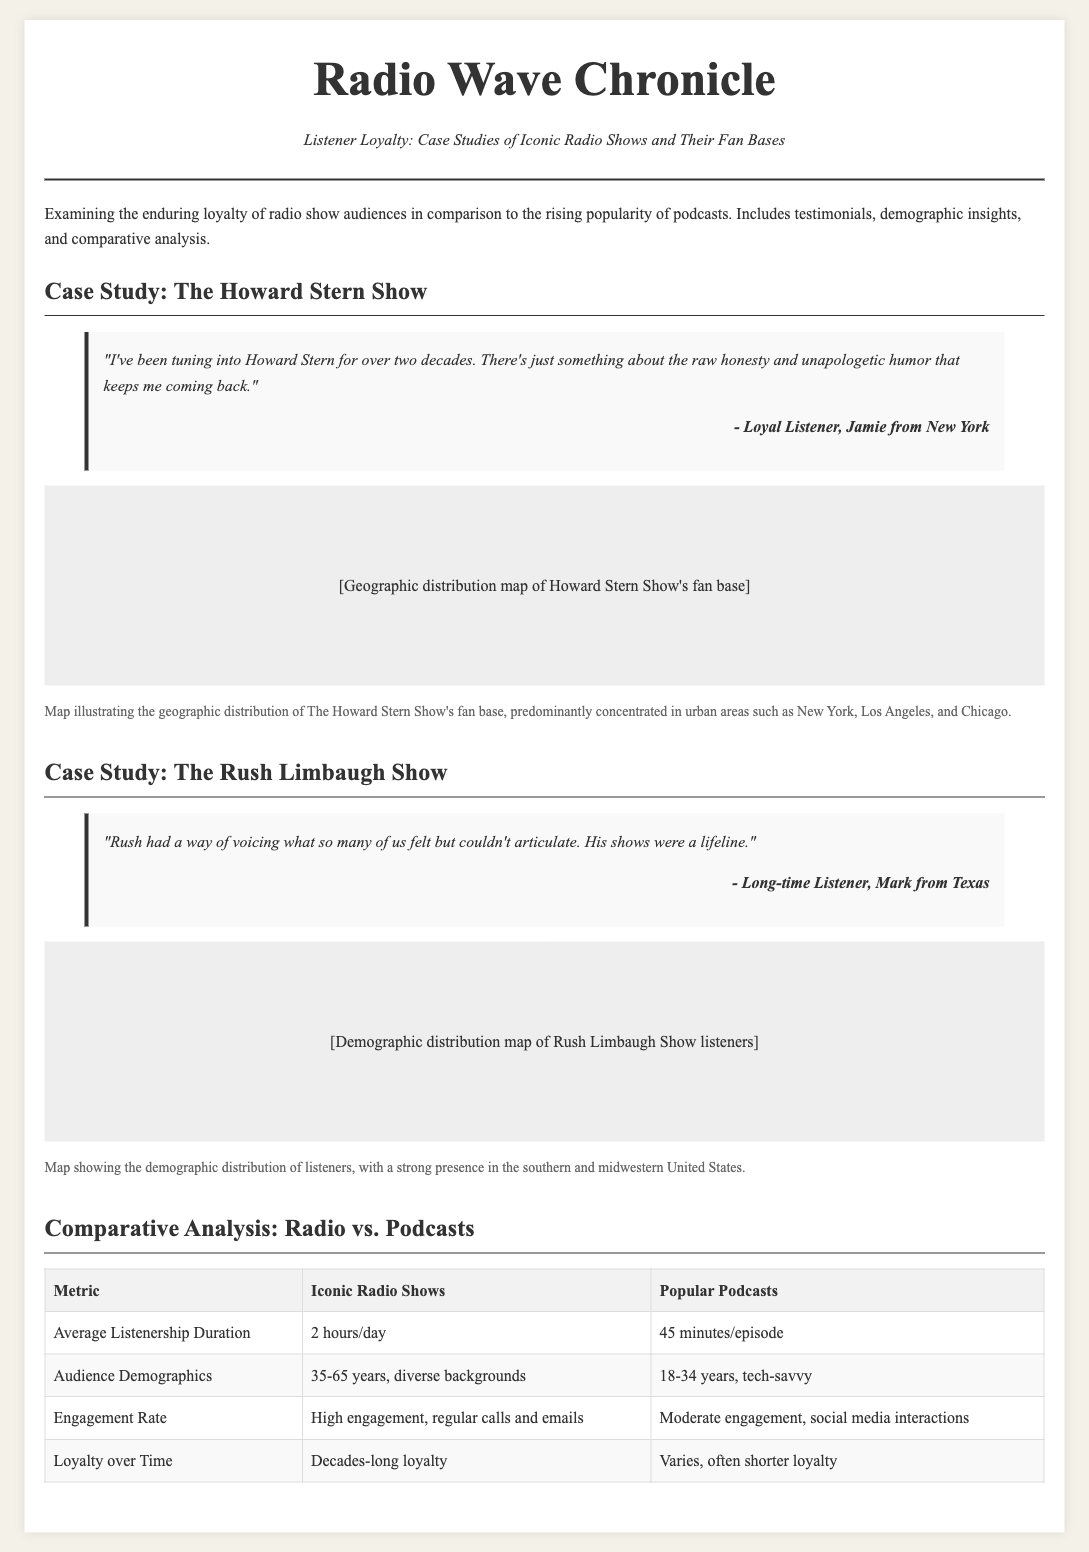what is the title of the article? The title is prominently displayed at the top of the newspaper layout.
Answer: Listener Loyalty: Case Studies of Iconic Radio Shows and Their Fan Bases who is the author of the testimonial for The Howard Stern Show? The author's name is mentioned in the testimonial section for The Howard Stern Show.
Answer: Jamie from New York what is the geographic concentration of The Howard Stern Show's fan base? The document describes the geographical distribution of The Howard Stern Show's audience.
Answer: Urban areas such as New York, Los Angeles, and Chicago what is the average listenership duration for Iconic Radio Shows? The average listenership duration is stated in the comparative analysis table.
Answer: 2 hours/day which age group is predominantly targeted by popular podcasts? The demographic information for popular podcasts is included in the comparative analysis.
Answer: 18-34 years what sentiment does Mark from Texas express in his testimonial about The Rush Limbaugh Show? The emotional expression in Mark's testimonial indicates how he valued the show.
Answer: Lifeline what engagement rate is associated with Iconic Radio Shows? The engagement rate is specified in the comparative analysis table.
Answer: High engagement, regular calls and emails how many words are used in the title section? The title section includes a specific number of words.
Answer: 12 words 